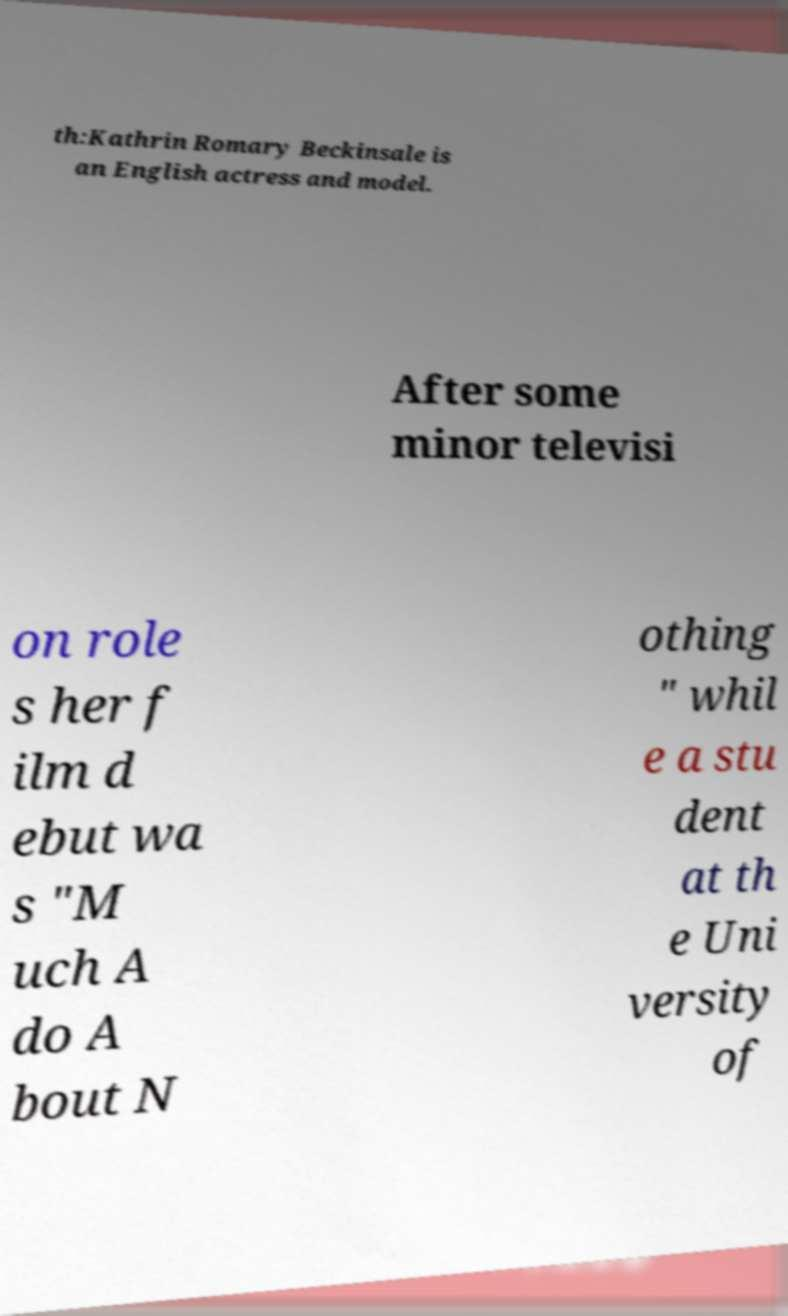Could you assist in decoding the text presented in this image and type it out clearly? th:Kathrin Romary Beckinsale is an English actress and model. After some minor televisi on role s her f ilm d ebut wa s "M uch A do A bout N othing " whil e a stu dent at th e Uni versity of 